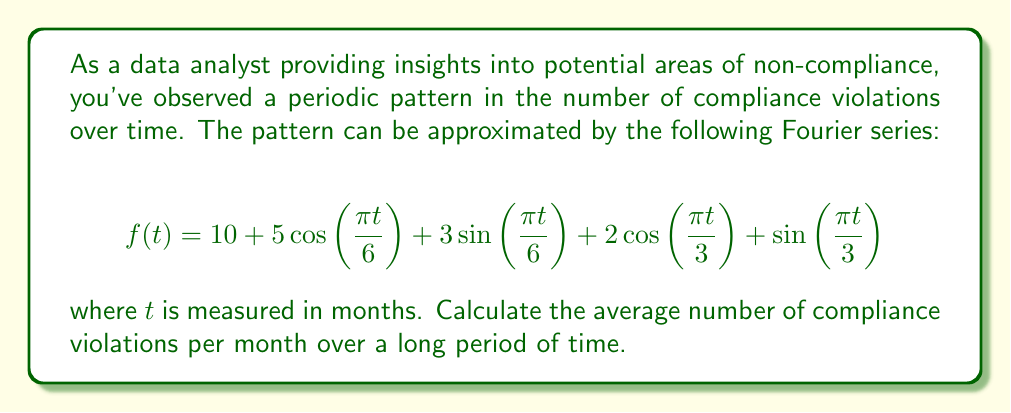Can you solve this math problem? To solve this problem, we need to understand a key property of Fourier series: the average value of a periodic function over its period is equal to the constant term (a₀) in its Fourier series representation.

Let's break down the given Fourier series:

$$f(t) = 10 + 5\cos(\frac{\pi t}{6}) + 3\sin(\frac{\pi t}{6}) + 2\cos(\frac{\pi t}{3}) + \sin(\frac{\pi t}{3})$$

In this series:
1. The constant term (a₀) is 10.
2. The other terms are periodic functions with different frequencies.

The periodic terms will oscillate above and below zero, but their average over a full period (or multiple periods) will be zero. Therefore, they do not contribute to the long-term average.

The constant term, 10, represents the average value of the function over its period. In this context, it represents the average number of compliance violations per month over a long period of time.

Thus, the average number of compliance violations per month is 10.
Answer: 10 violations per month 